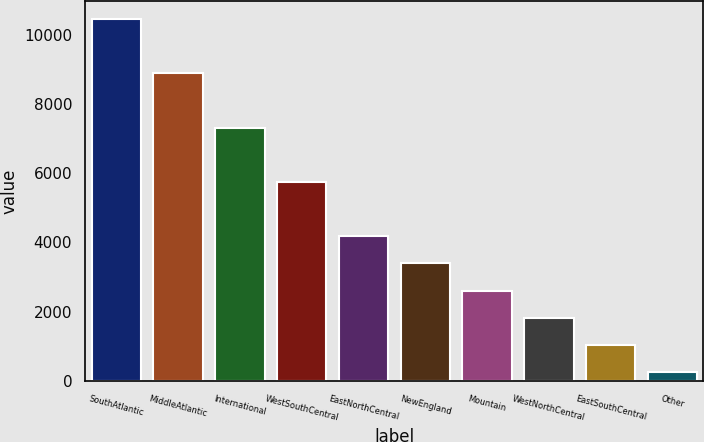Convert chart to OTSL. <chart><loc_0><loc_0><loc_500><loc_500><bar_chart><fcel>SouthAtlantic<fcel>MiddleAtlantic<fcel>International<fcel>WestSouthCentral<fcel>EastNorthCentral<fcel>NewEngland<fcel>Mountain<fcel>WestNorthCentral<fcel>EastSouthCentral<fcel>Other<nl><fcel>10454.5<fcel>8885.5<fcel>7316.5<fcel>5747.5<fcel>4178.5<fcel>3394<fcel>2609.5<fcel>1825<fcel>1040.5<fcel>256<nl></chart> 